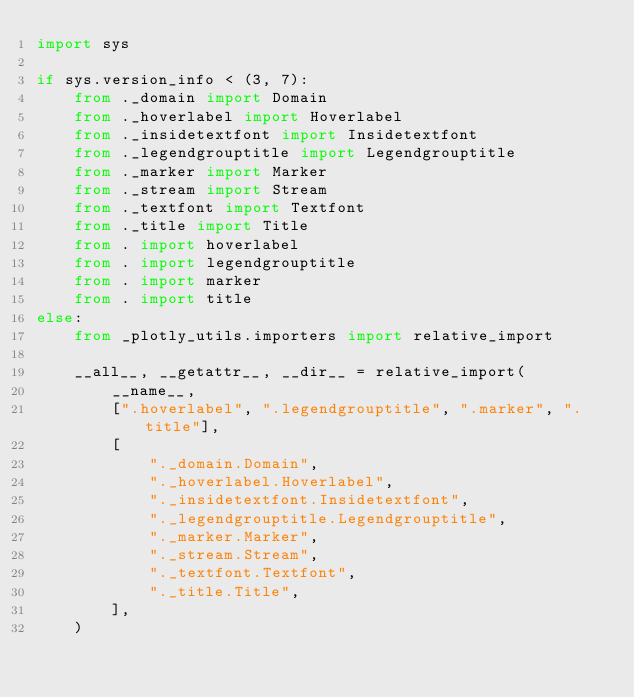<code> <loc_0><loc_0><loc_500><loc_500><_Python_>import sys

if sys.version_info < (3, 7):
    from ._domain import Domain
    from ._hoverlabel import Hoverlabel
    from ._insidetextfont import Insidetextfont
    from ._legendgrouptitle import Legendgrouptitle
    from ._marker import Marker
    from ._stream import Stream
    from ._textfont import Textfont
    from ._title import Title
    from . import hoverlabel
    from . import legendgrouptitle
    from . import marker
    from . import title
else:
    from _plotly_utils.importers import relative_import

    __all__, __getattr__, __dir__ = relative_import(
        __name__,
        [".hoverlabel", ".legendgrouptitle", ".marker", ".title"],
        [
            "._domain.Domain",
            "._hoverlabel.Hoverlabel",
            "._insidetextfont.Insidetextfont",
            "._legendgrouptitle.Legendgrouptitle",
            "._marker.Marker",
            "._stream.Stream",
            "._textfont.Textfont",
            "._title.Title",
        ],
    )
</code> 